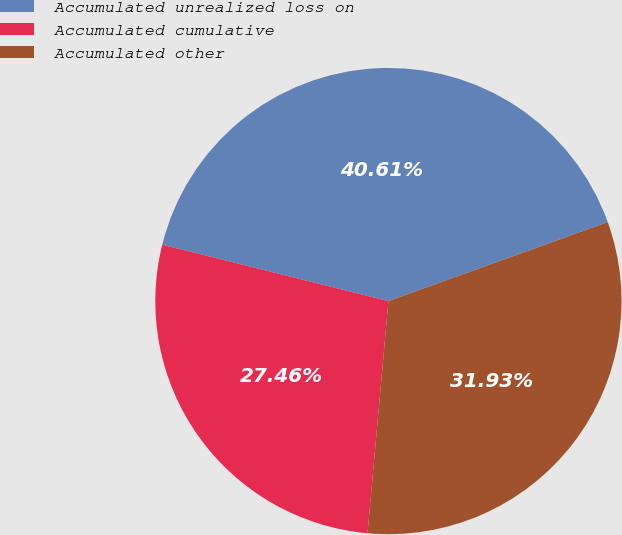Convert chart. <chart><loc_0><loc_0><loc_500><loc_500><pie_chart><fcel>Accumulated unrealized loss on<fcel>Accumulated cumulative<fcel>Accumulated other<nl><fcel>40.61%<fcel>27.46%<fcel>31.93%<nl></chart> 